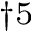Convert formula to latex. <formula><loc_0><loc_0><loc_500><loc_500>^ { \dag 5 }</formula> 